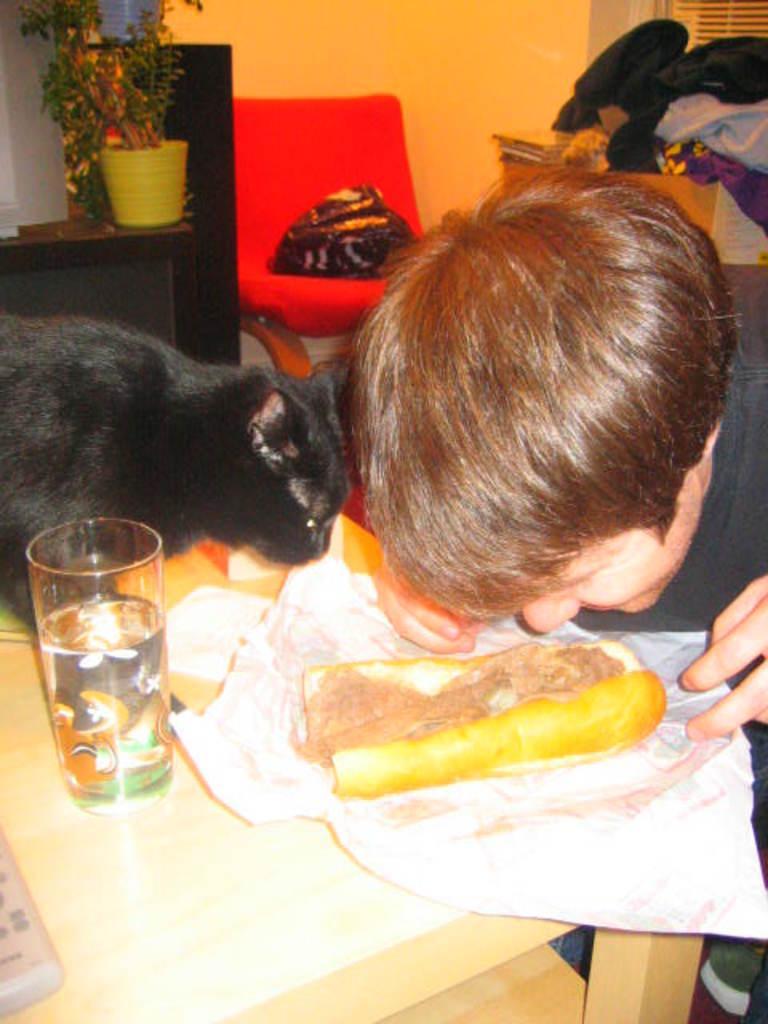Can you describe this image briefly? In the picture I can see the table. At the top of the table I can see food item, glass and animal. On the right side of the image I can see one person. In the background, I can see plants and some other objects. 